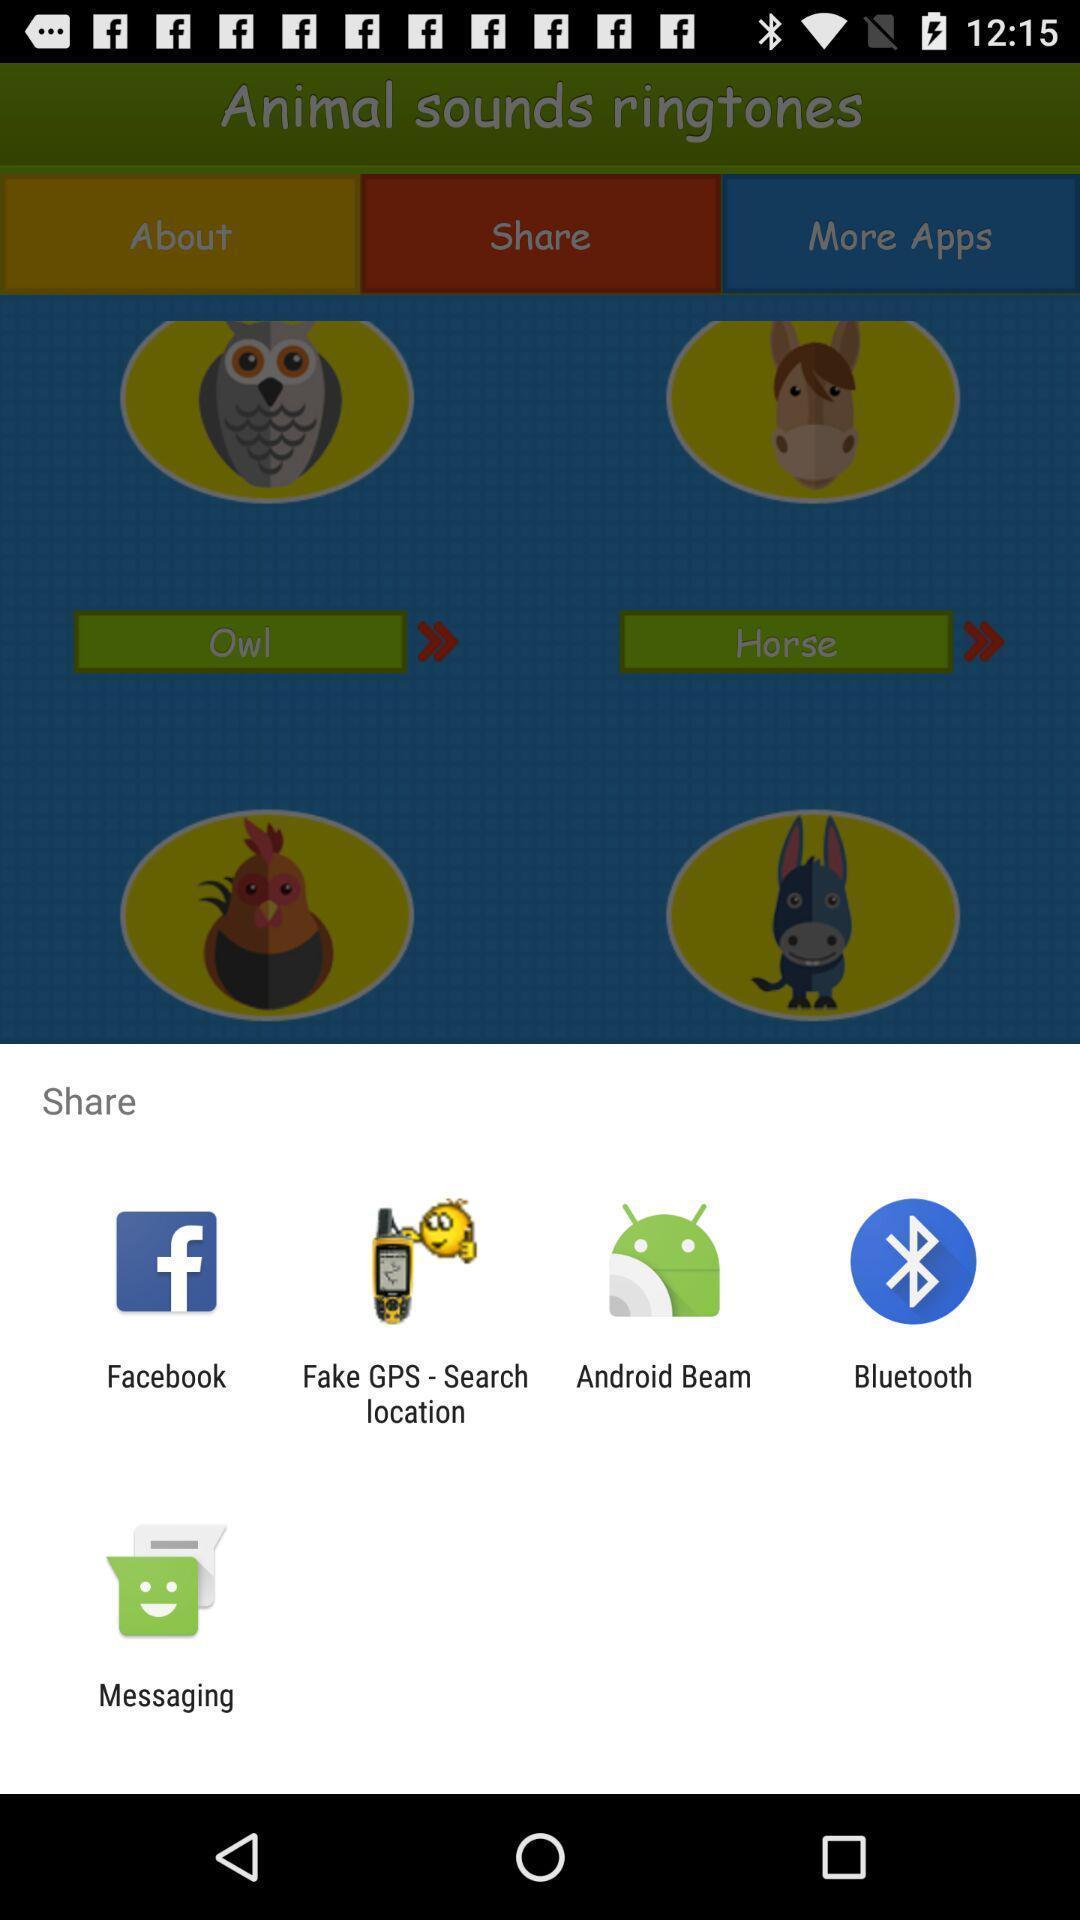Provide a description of this screenshot. Push up message for sharing data via social network. 